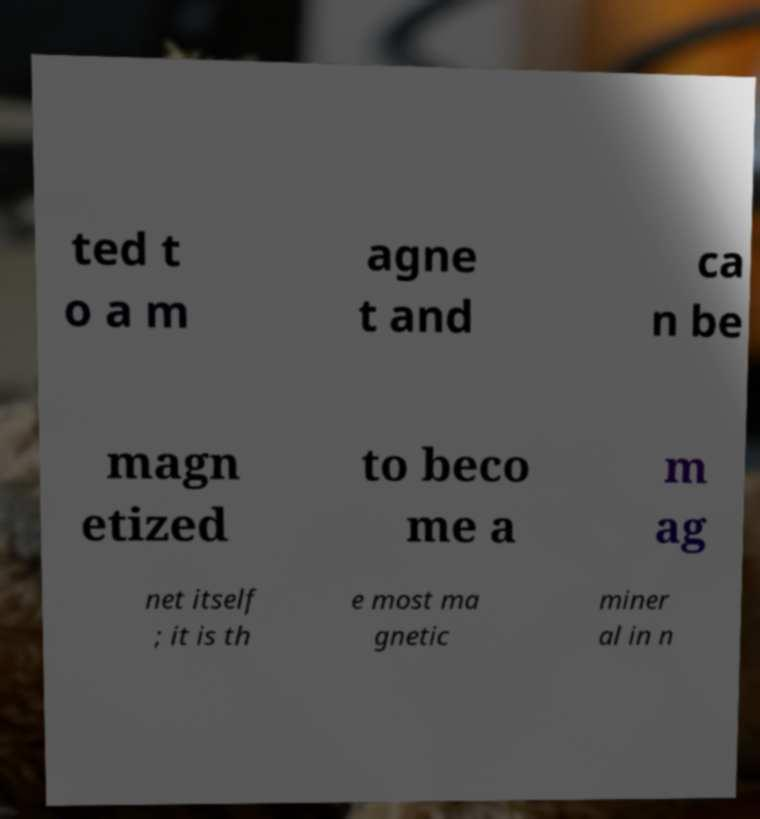For documentation purposes, I need the text within this image transcribed. Could you provide that? ted t o a m agne t and ca n be magn etized to beco me a m ag net itself ; it is th e most ma gnetic miner al in n 